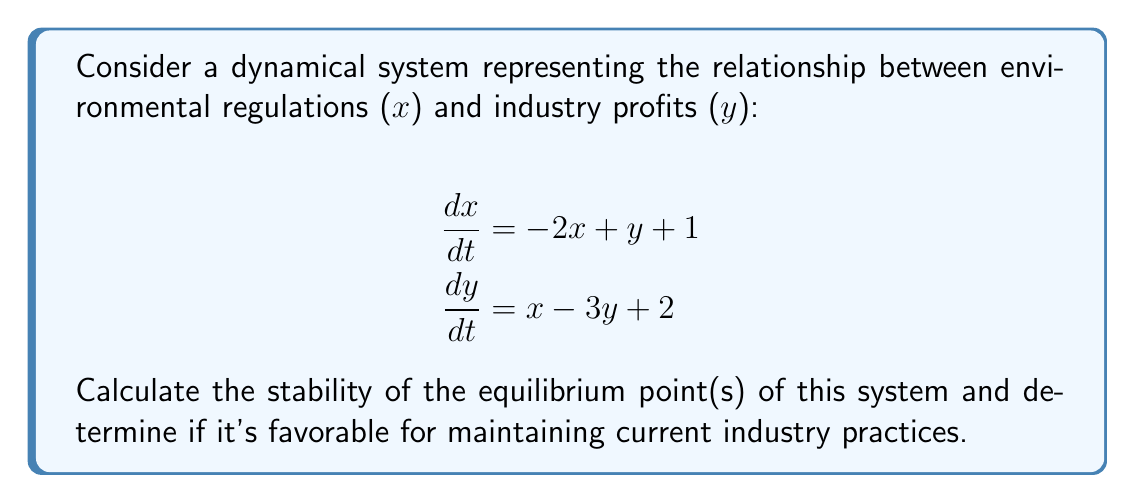Could you help me with this problem? 1) First, find the equilibrium point(s) by setting both equations to zero:

   $-2x + y + 1 = 0$ and $x - 3y + 2 = 0$

2) Solve this system of equations:
   From the second equation: $x = 3y - 2$
   Substitute into the first equation:
   $-2(3y - 2) + y + 1 = 0$
   $-6y + 4 + y + 1 = 0$
   $-5y + 5 = 0$
   $y = 1$

   Substitute back to find $x$:
   $x = 3(1) - 2 = 1$

   The equilibrium point is $(1, 1)$

3) To determine stability, calculate the Jacobian matrix at the equilibrium point:

   $$J = \begin{bmatrix}
   \frac{\partial f_1}{\partial x} & \frac{\partial f_1}{\partial y} \\
   \frac{\partial f_2}{\partial x} & \frac{\partial f_2}{\partial y}
   \end{bmatrix} = \begin{bmatrix}
   -2 & 1 \\
   1 & -3
   \end{bmatrix}$$

4) Calculate the eigenvalues of the Jacobian:
   $det(J - \lambda I) = 0$

   $$\begin{vmatrix}
   -2-\lambda & 1 \\
   1 & -3-\lambda
   \end{vmatrix} = 0$$

   $(-2-\lambda)(-3-\lambda) - 1 = 0$
   $\lambda^2 + 5\lambda + 5 = 0$

5) Solve this quadratic equation:
   $\lambda = \frac{-5 \pm \sqrt{25 - 20}}{2} = \frac{-5 \pm \sqrt{5}}{2}$

   Both eigenvalues have negative real parts.

6) Since both eigenvalues have negative real parts, the equilibrium point is asymptotically stable.

7) For industry practices, stability means that any small deviation from the equilibrium will return to it over time. This suggests that current environmental regulations and profit levels will tend to persist, which is generally favorable for maintaining current industry practices.
Answer: Asymptotically stable at (1,1); favorable for current industry practices 